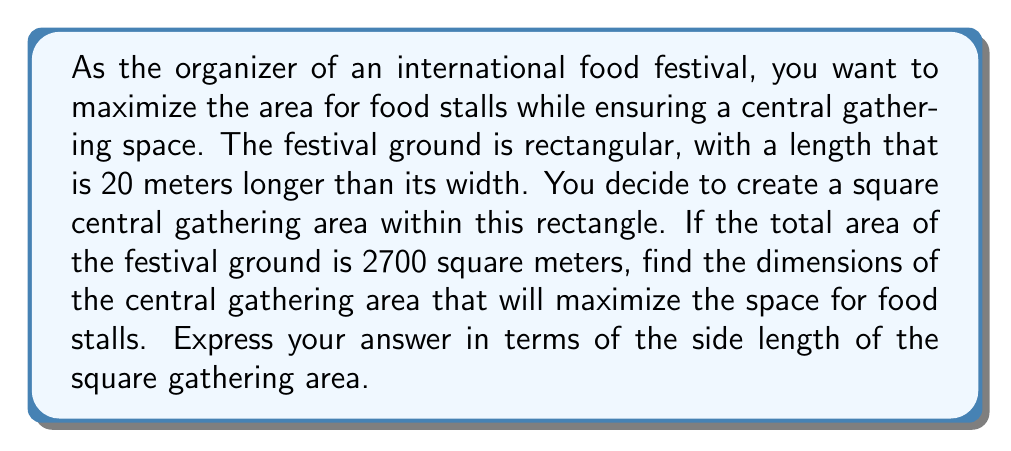Teach me how to tackle this problem. Let's approach this step-by-step:

1) Let $x$ be the width of the rectangular festival ground, and $y$ be its length.
   We know that $y = x + 20$

2) The area of the rectangle is 2700 sq meters:
   $xy = 2700$
   $x(x + 20) = 2700$
   $x^2 + 20x - 2700 = 0$

3) Let $s$ be the side length of the square gathering area.
   The area for food stalls will be the total area minus the area of the square:
   $A_{stalls} = xy - s^2 = 2700 - s^2$

4) To express this in terms of $s$, we need to find $x$ and $y$ in terms of $s$:
   $x = s + a$ and $y = s + b$, where $a$ and $b$ are the widths of the stall areas

5) Substituting into the equation from step 2:
   $(s + a)(s + b) = 2700$
   $s^2 + (a + b)s + ab = 2700$

6) We also know that $b = a + 20$ (from step 1)
   $s^2 + (2a + 20)s + a(a + 20) = 2700$

7) The area of the stalls is:
   $A_{stalls} = xa + yb = (s + a)a + (s + a + 20)(a + 20)$
               $= sa + a^2 + sa + a^2 + 20s + 20a + 20a + 400$
               $= 2sa + 2a^2 + 40a + 20s + 400$

8) To maximize this, we differentiate with respect to $a$ and set to zero:
   $\frac{dA_{stalls}}{da} = 2s + 4a + 40 = 0$
   $a = -\frac{s + 20}{2}$

9) Substituting this back into the equation from step 6:
   $s^2 + (2(-\frac{s + 20}{2}) + 20)s + (-\frac{s + 20}{2})(-\frac{s + 20}{2} + 20) = 2700$
   $s^2 + (-s - 20 + 20)s + (-\frac{s + 20}{2})(\frac{-s + 20}{2}) = 2700$
   $s^2 - s + \frac{s^2 - 400}{4} = 2700$
   $4s^2 - 4s + s^2 - 400 = 10800$
   $5s^2 - 4s - 11200 = 0$

10) Solving this quadratic equation:
    $s = \frac{4 \pm \sqrt{16 + 4(5)(11200)}}{10} = \frac{4 \pm \sqrt{224016}}{10} = \frac{4 \pm 473.3}{10}$

11) Taking the positive root (as length can't be negative):
    $s = \frac{4 + 473.3}{10} \approx 47.73$ meters
Answer: The dimensions of the central gathering area that will maximize the space for food stalls is approximately 47.73 meters by 47.73 meters. 